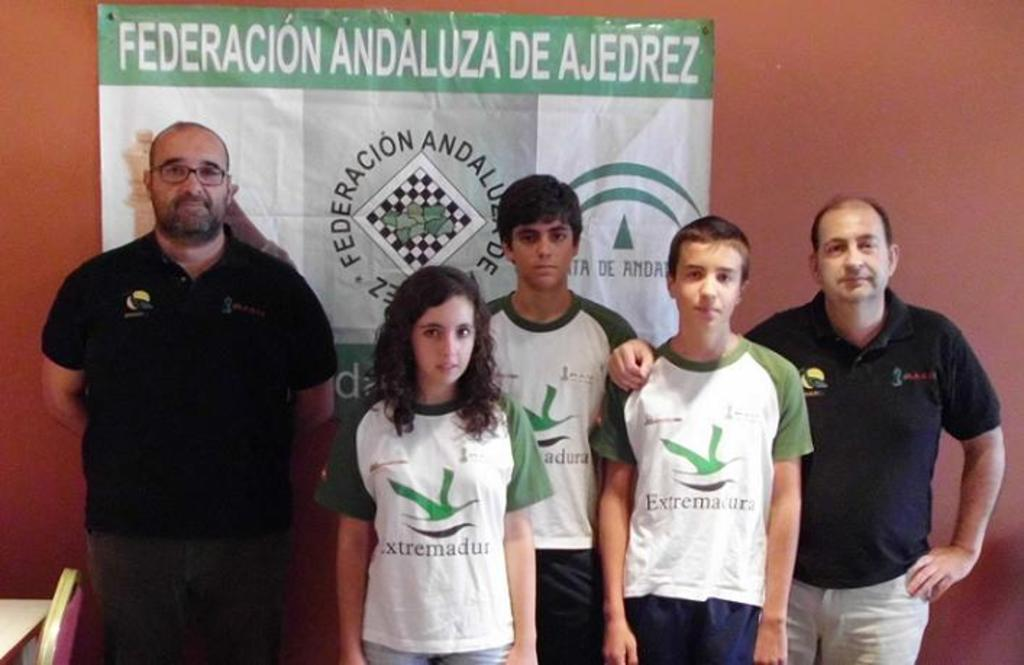<image>
Share a concise interpretation of the image provided. Three teenagers wearing matching shirts stand between to men in front of a banner titled Federacion Andaluza De Ajedrez. 